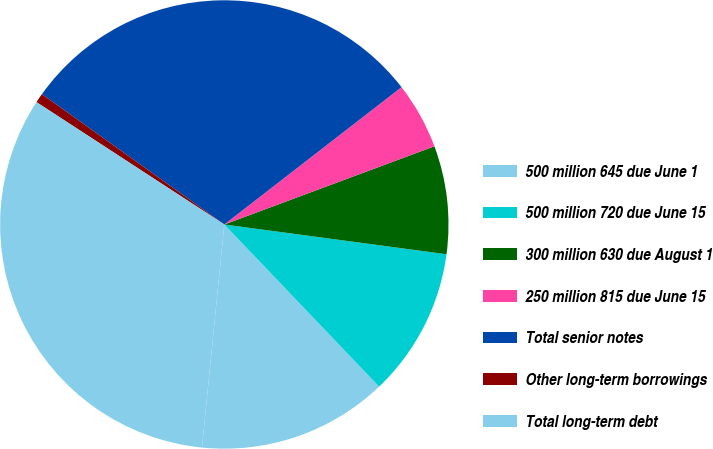<chart> <loc_0><loc_0><loc_500><loc_500><pie_chart><fcel>500 million 645 due June 1<fcel>500 million 720 due June 15<fcel>300 million 630 due August 1<fcel>250 million 815 due June 15<fcel>Total senior notes<fcel>Other long-term borrowings<fcel>Total long-term debt<nl><fcel>13.72%<fcel>10.75%<fcel>7.79%<fcel>4.82%<fcel>29.64%<fcel>0.68%<fcel>32.6%<nl></chart> 